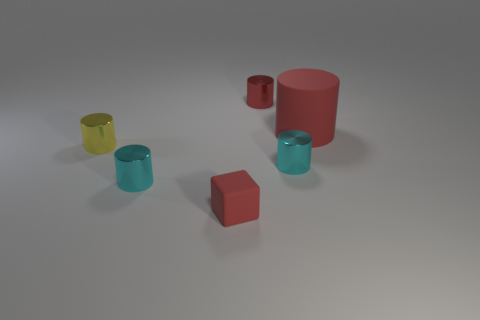The red matte object that is to the left of the small red object behind the cyan shiny cylinder to the left of the block is what shape?
Make the answer very short. Cube. Does the red block have the same size as the red metal cylinder behind the large red object?
Provide a short and direct response. Yes. The metal thing that is right of the small yellow cylinder and left of the tiny matte cube is what color?
Your answer should be very brief. Cyan. What number of other objects are there of the same shape as the big object?
Offer a very short reply. 4. Do the small cylinder behind the yellow shiny object and the matte object in front of the small yellow object have the same color?
Ensure brevity in your answer.  Yes. There is a cyan metallic thing left of the tiny matte cube; is it the same size as the red cylinder in front of the small red metallic object?
Offer a terse response. No. Is there any other thing that has the same material as the tiny red cylinder?
Offer a very short reply. Yes. What is the material of the cyan object that is on the left side of the thing that is in front of the cyan object that is left of the tiny red shiny cylinder?
Your answer should be compact. Metal. Is the big object the same shape as the small red matte thing?
Ensure brevity in your answer.  No. There is a large object that is the same shape as the small red shiny object; what material is it?
Make the answer very short. Rubber. 